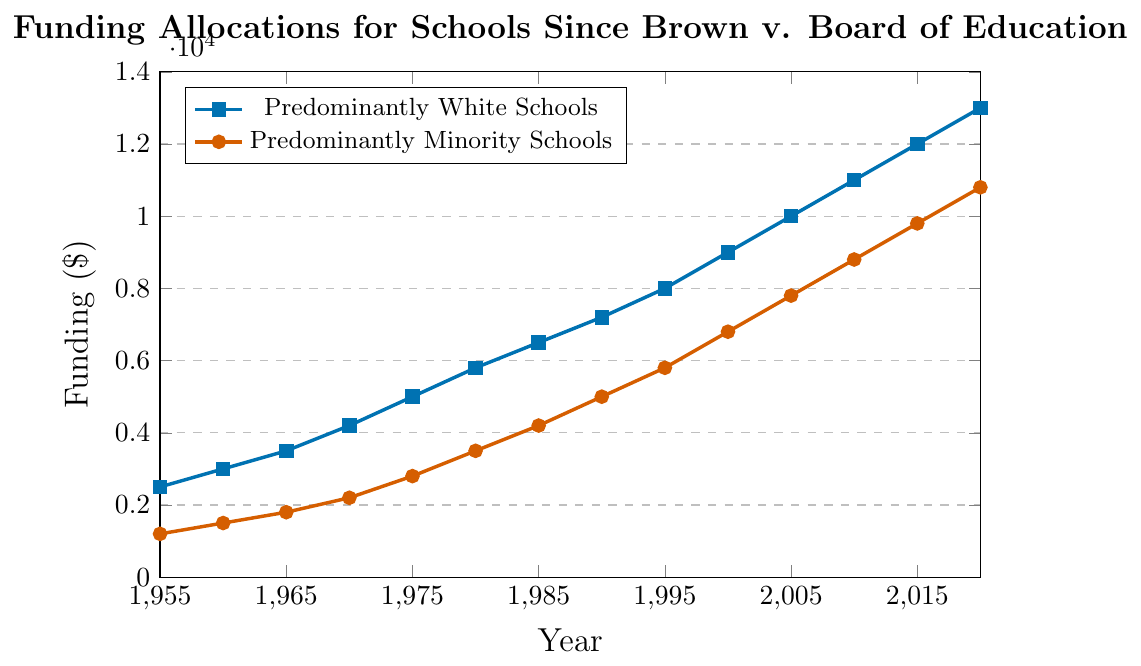What is the funding difference between predominantly white schools and predominantly minority schools in 1980? In 1980, the funding for predominantly white schools is $5800 and for predominantly minority schools is $3500. The difference is $5800 - $3500 = $2300.
Answer: $2300 When did the funding for predominantly minority schools first exceed $5000? According to the data, predominantly minority schools' funding first exceeds $5000 in 1990, with the amount being $5000.
Answer: 1990 By how much did the funding for predominantly minority schools increase from 1975 to 1985? In 1975, the funding for predominantly minority schools was $2800, and in 1985, it was $4200. The increase is $4200 - $2800 = $1400.
Answer: $1400 Between 1970 and 1980, which type of schools saw a higher absolute increase in funding? For predominantly white schools, the funding increased from $4200 in 1970 to $5800 in 1980, an increase of $1600. For predominantly minority schools, the funding increased from $2200 in 1970 to $3500 in 1980, an increase of $1300. Thus, predominantly white schools saw a higher increase.
Answer: Predominantly white schools How did the funding for predominantly minority schools in 2010 compare to the funding for predominantly white schools in 1995? In 2010, the funding for predominantly minority schools was $8800. In 1995, the funding for predominantly white schools was $8000. Therefore, the funding for predominantly minority schools in 2010 was higher than that for predominantly white schools in 1995.
Answer: Higher What's the average funding for predominantly white schools over the decades recorded? The sum of the funding values for predominantly white schools over all years is (2500 + 3000 + 3500 + 4200 + 5000 + 5800 + 6500 + 7200 + 8000 + 9000 + 10000 + 11000 + 12000 + 13000) = $99100. There are 14 data points, so the average is $99100 / 14 = $7078.57 approximately.
Answer: $7078.57 Which type of schools had a higher percentage increase in funding from 2000 to 2005? From 2000 to 2005, predominantly white schools’ funding increased from $9000 to $10000, a $1000 increase, which is (1000 / 9000) * 100 ≈ 11.11%. For predominantly minority schools, funding increased from $6800 to $7800, a $1000 increase, which is (1000 / 6800) * 100 ≈ 14.71%. Predominantly minority schools had a higher percentage increase.
Answer: Predominantly minority schools What is the trend in funding for predominantly minority schools from 1955 to 2020? The funding for predominantly minority schools shows a steady increase over the years from $1200 in 1955 to $10800 in 2020, indicating a positive trend.
Answer: Steady increase By how much did the funding gap between predominantly white and minority schools decrease from 1955 to 2020? In 1955, the gap was $2500 (white) - $1200 (minority) = $1300. In 2020, the gap was $13000 (white) - $10800 (minority) = $2200. So, the gap actually increased by $2200 - $1300 = $900.
Answer: Increased by $900 